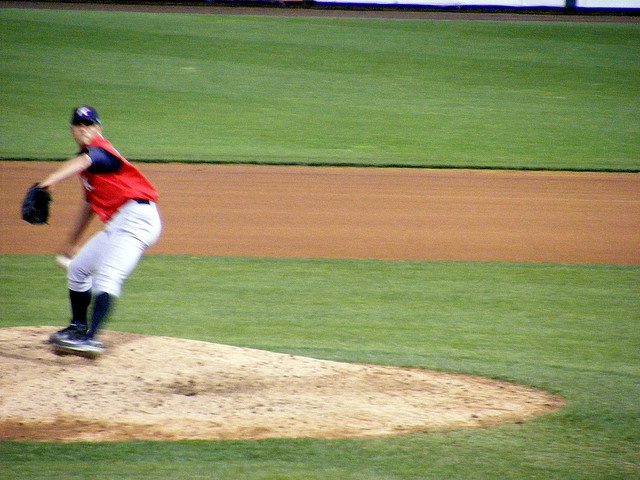Describe the objects in this image and their specific colors. I can see people in black, lavender, brown, and red tones, baseball glove in black, gray, and brown tones, and sports ball in black, beige, olive, and darkgray tones in this image. 